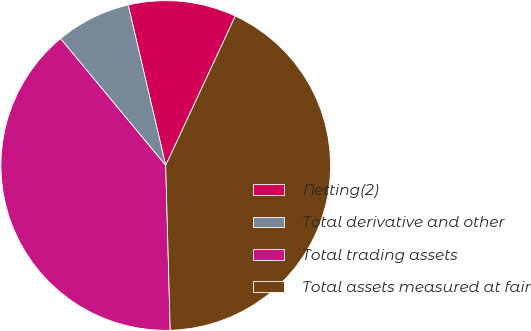<chart> <loc_0><loc_0><loc_500><loc_500><pie_chart><fcel>Netting(2)<fcel>Total derivative and other<fcel>Total trading assets<fcel>Total assets measured at fair<nl><fcel>10.6%<fcel>7.36%<fcel>39.42%<fcel>42.63%<nl></chart> 